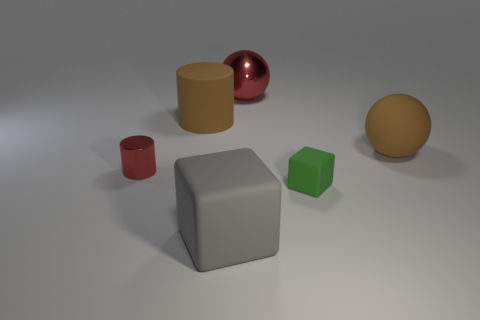What number of big matte things are in front of the red shiny thing in front of the brown rubber cylinder?
Keep it short and to the point. 1. There is a brown cylinder; are there any large balls in front of it?
Make the answer very short. Yes. There is a object that is to the right of the small green rubber block; is it the same shape as the gray rubber object?
Give a very brief answer. No. What is the material of the cylinder that is the same color as the large matte sphere?
Keep it short and to the point. Rubber. How many large objects have the same color as the matte cylinder?
Provide a short and direct response. 1. What shape is the big brown rubber thing that is to the right of the big brown thing that is left of the brown ball?
Keep it short and to the point. Sphere. Is there a green matte thing of the same shape as the gray rubber object?
Your answer should be very brief. Yes. Does the metallic cylinder have the same color as the big ball that is left of the small matte object?
Give a very brief answer. Yes. There is a metal cylinder that is the same color as the shiny sphere; what size is it?
Your answer should be very brief. Small. Are there any gray blocks that have the same size as the brown matte ball?
Ensure brevity in your answer.  Yes. 